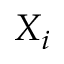Convert formula to latex. <formula><loc_0><loc_0><loc_500><loc_500>X _ { i }</formula> 